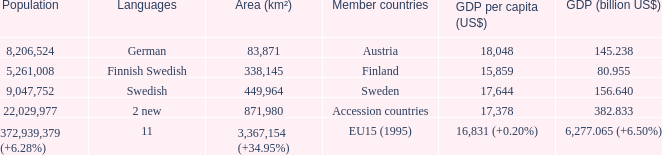Name the member countries for finnish swedish Finland. 